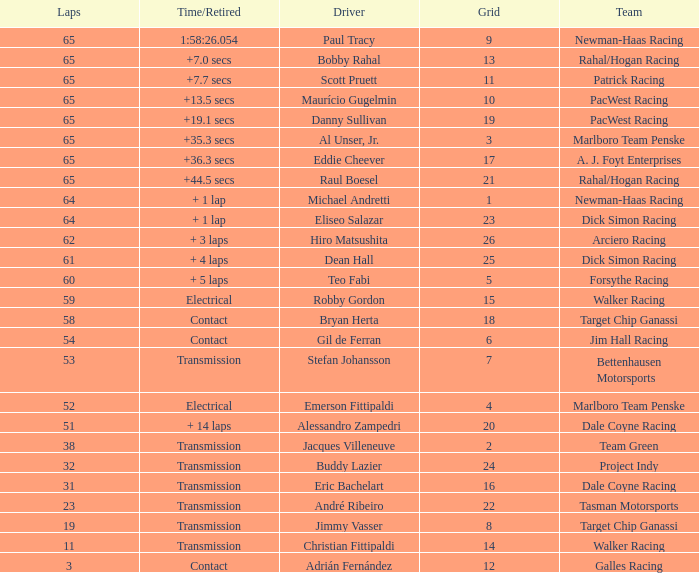What was the highest grid for a time/retired of +19.1 secs? 19.0. 